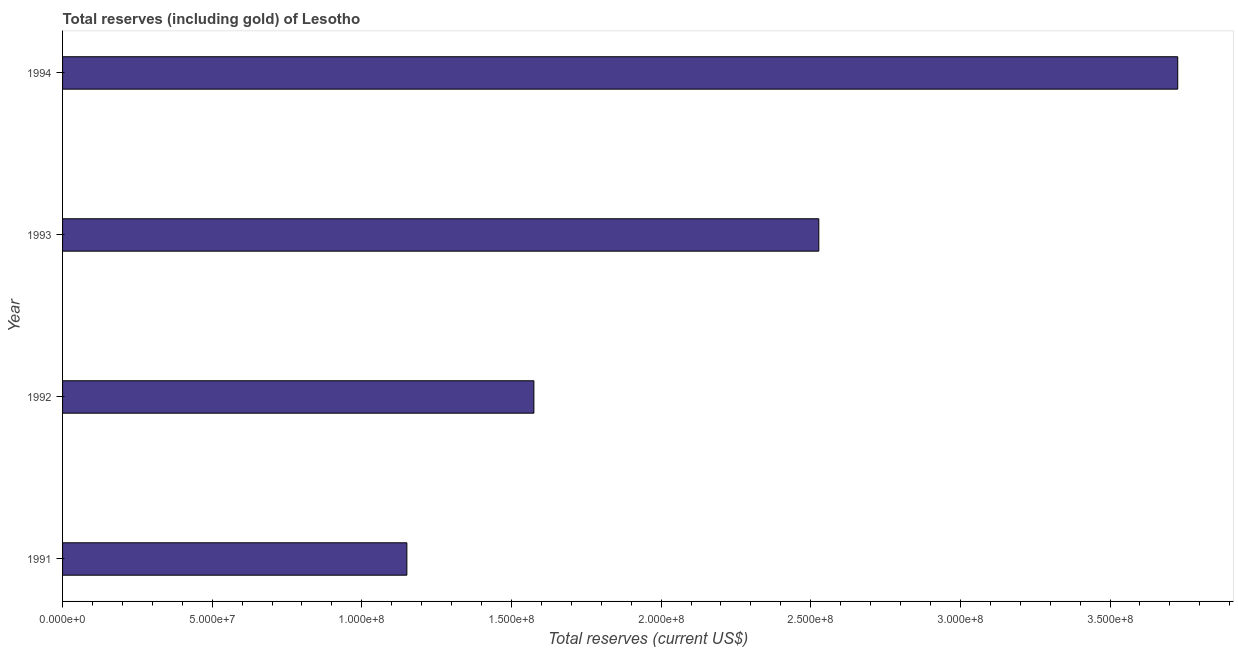What is the title of the graph?
Ensure brevity in your answer.  Total reserves (including gold) of Lesotho. What is the label or title of the X-axis?
Give a very brief answer. Total reserves (current US$). What is the label or title of the Y-axis?
Provide a succinct answer. Year. What is the total reserves (including gold) in 1992?
Offer a terse response. 1.57e+08. Across all years, what is the maximum total reserves (including gold)?
Ensure brevity in your answer.  3.73e+08. Across all years, what is the minimum total reserves (including gold)?
Your answer should be compact. 1.15e+08. In which year was the total reserves (including gold) maximum?
Make the answer very short. 1994. What is the sum of the total reserves (including gold)?
Offer a terse response. 8.98e+08. What is the difference between the total reserves (including gold) in 1992 and 1993?
Your answer should be very brief. -9.52e+07. What is the average total reserves (including gold) per year?
Make the answer very short. 2.24e+08. What is the median total reserves (including gold)?
Provide a succinct answer. 2.05e+08. In how many years, is the total reserves (including gold) greater than 70000000 US$?
Ensure brevity in your answer.  4. Do a majority of the years between 1992 and 1994 (inclusive) have total reserves (including gold) greater than 220000000 US$?
Provide a succinct answer. Yes. What is the ratio of the total reserves (including gold) in 1991 to that in 1994?
Your answer should be compact. 0.31. Is the difference between the total reserves (including gold) in 1993 and 1994 greater than the difference between any two years?
Keep it short and to the point. No. What is the difference between the highest and the second highest total reserves (including gold)?
Your answer should be very brief. 1.20e+08. What is the difference between the highest and the lowest total reserves (including gold)?
Your response must be concise. 2.58e+08. In how many years, is the total reserves (including gold) greater than the average total reserves (including gold) taken over all years?
Provide a succinct answer. 2. Are all the bars in the graph horizontal?
Provide a short and direct response. Yes. How many years are there in the graph?
Keep it short and to the point. 4. What is the difference between two consecutive major ticks on the X-axis?
Your answer should be compact. 5.00e+07. Are the values on the major ticks of X-axis written in scientific E-notation?
Your answer should be very brief. Yes. What is the Total reserves (current US$) in 1991?
Offer a very short reply. 1.15e+08. What is the Total reserves (current US$) of 1992?
Provide a succinct answer. 1.57e+08. What is the Total reserves (current US$) of 1993?
Your answer should be very brief. 2.53e+08. What is the Total reserves (current US$) in 1994?
Keep it short and to the point. 3.73e+08. What is the difference between the Total reserves (current US$) in 1991 and 1992?
Give a very brief answer. -4.24e+07. What is the difference between the Total reserves (current US$) in 1991 and 1993?
Provide a short and direct response. -1.38e+08. What is the difference between the Total reserves (current US$) in 1991 and 1994?
Ensure brevity in your answer.  -2.58e+08. What is the difference between the Total reserves (current US$) in 1992 and 1993?
Your answer should be compact. -9.52e+07. What is the difference between the Total reserves (current US$) in 1992 and 1994?
Make the answer very short. -2.15e+08. What is the difference between the Total reserves (current US$) in 1993 and 1994?
Your answer should be compact. -1.20e+08. What is the ratio of the Total reserves (current US$) in 1991 to that in 1992?
Your response must be concise. 0.73. What is the ratio of the Total reserves (current US$) in 1991 to that in 1993?
Your answer should be very brief. 0.46. What is the ratio of the Total reserves (current US$) in 1991 to that in 1994?
Your response must be concise. 0.31. What is the ratio of the Total reserves (current US$) in 1992 to that in 1993?
Your answer should be very brief. 0.62. What is the ratio of the Total reserves (current US$) in 1992 to that in 1994?
Provide a short and direct response. 0.42. What is the ratio of the Total reserves (current US$) in 1993 to that in 1994?
Offer a very short reply. 0.68. 